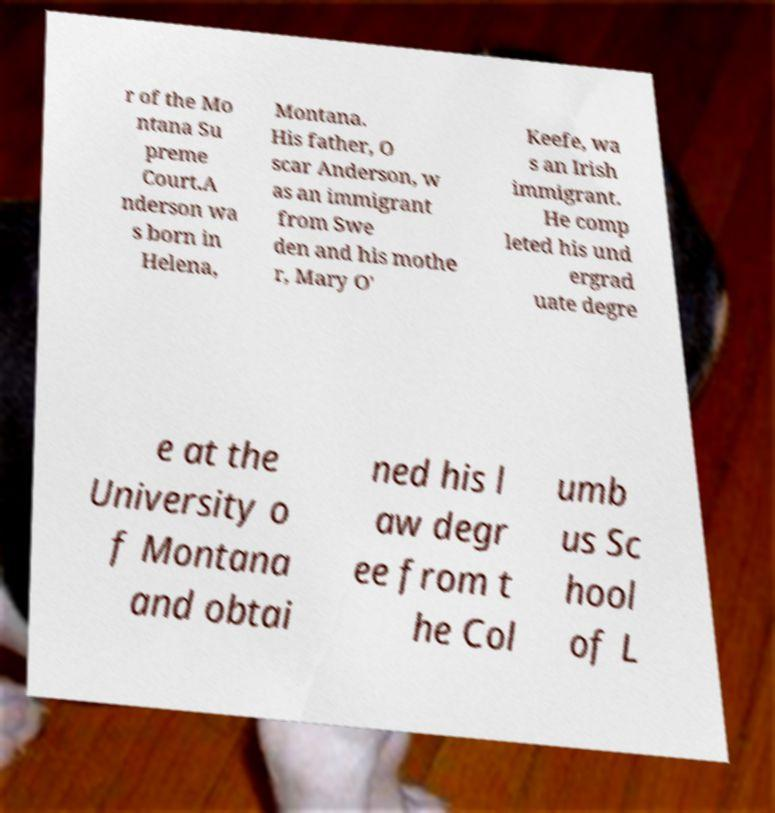There's text embedded in this image that I need extracted. Can you transcribe it verbatim? r of the Mo ntana Su preme Court.A nderson wa s born in Helena, Montana. His father, O scar Anderson, w as an immigrant from Swe den and his mothe r, Mary O' Keefe, wa s an Irish immigrant. He comp leted his und ergrad uate degre e at the University o f Montana and obtai ned his l aw degr ee from t he Col umb us Sc hool of L 